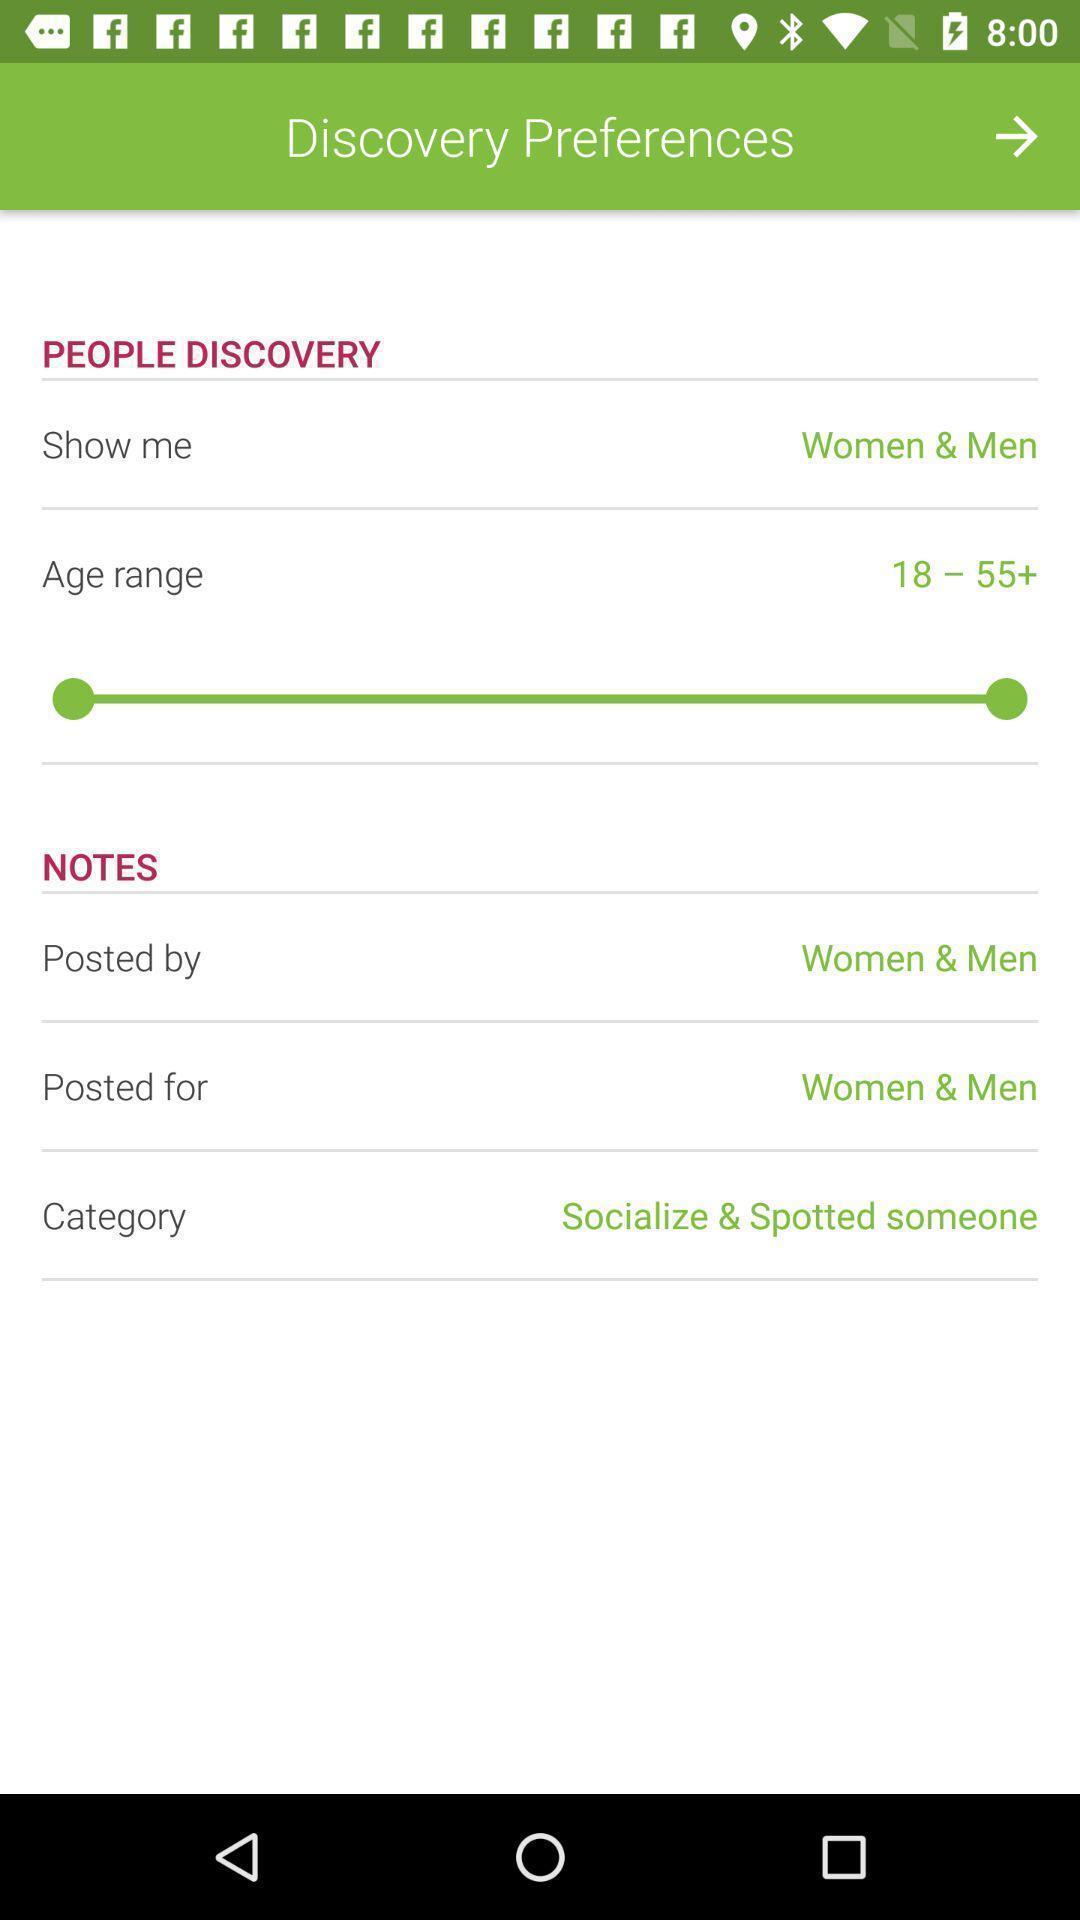What details can you identify in this image? Setting page of preferences for an app. 